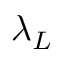<formula> <loc_0><loc_0><loc_500><loc_500>\lambda _ { L }</formula> 